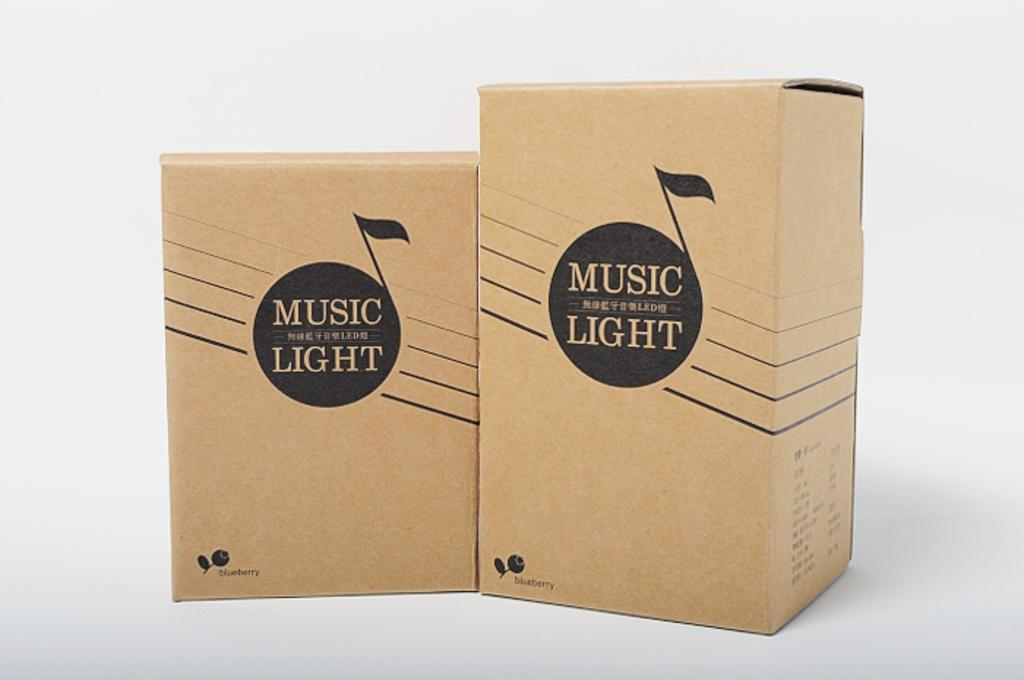<image>
Relay a brief, clear account of the picture shown. two card board boxes reading Music and Light in a big music note 